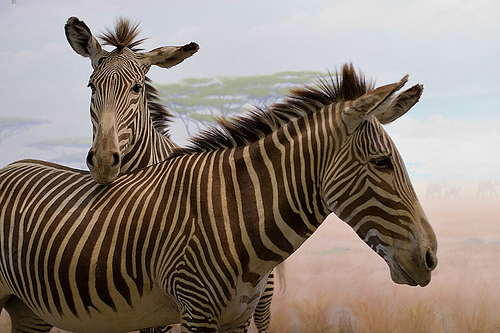Describe the interaction between the two zebras seen in the image. The image captures a tender moment between two zebras, likely exhibiting social bonding as one rests its head slightly on the other, emphasizing their gregarious nature. 